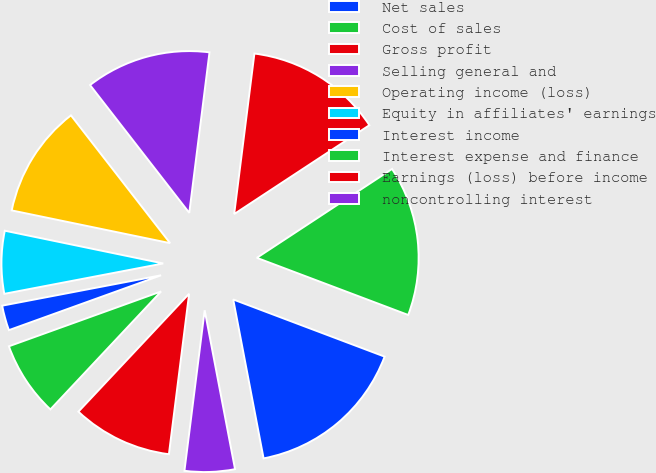<chart> <loc_0><loc_0><loc_500><loc_500><pie_chart><fcel>Net sales<fcel>Cost of sales<fcel>Gross profit<fcel>Selling general and<fcel>Operating income (loss)<fcel>Equity in affiliates' earnings<fcel>Interest income<fcel>Interest expense and finance<fcel>Earnings (loss) before income<fcel>noncontrolling interest<nl><fcel>16.25%<fcel>15.0%<fcel>13.75%<fcel>12.5%<fcel>11.25%<fcel>6.25%<fcel>2.5%<fcel>7.5%<fcel>10.0%<fcel>5.0%<nl></chart> 